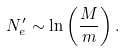Convert formula to latex. <formula><loc_0><loc_0><loc_500><loc_500>N _ { e } ^ { \prime } \sim \ln \left ( \frac { M } { m } \right ) .</formula> 